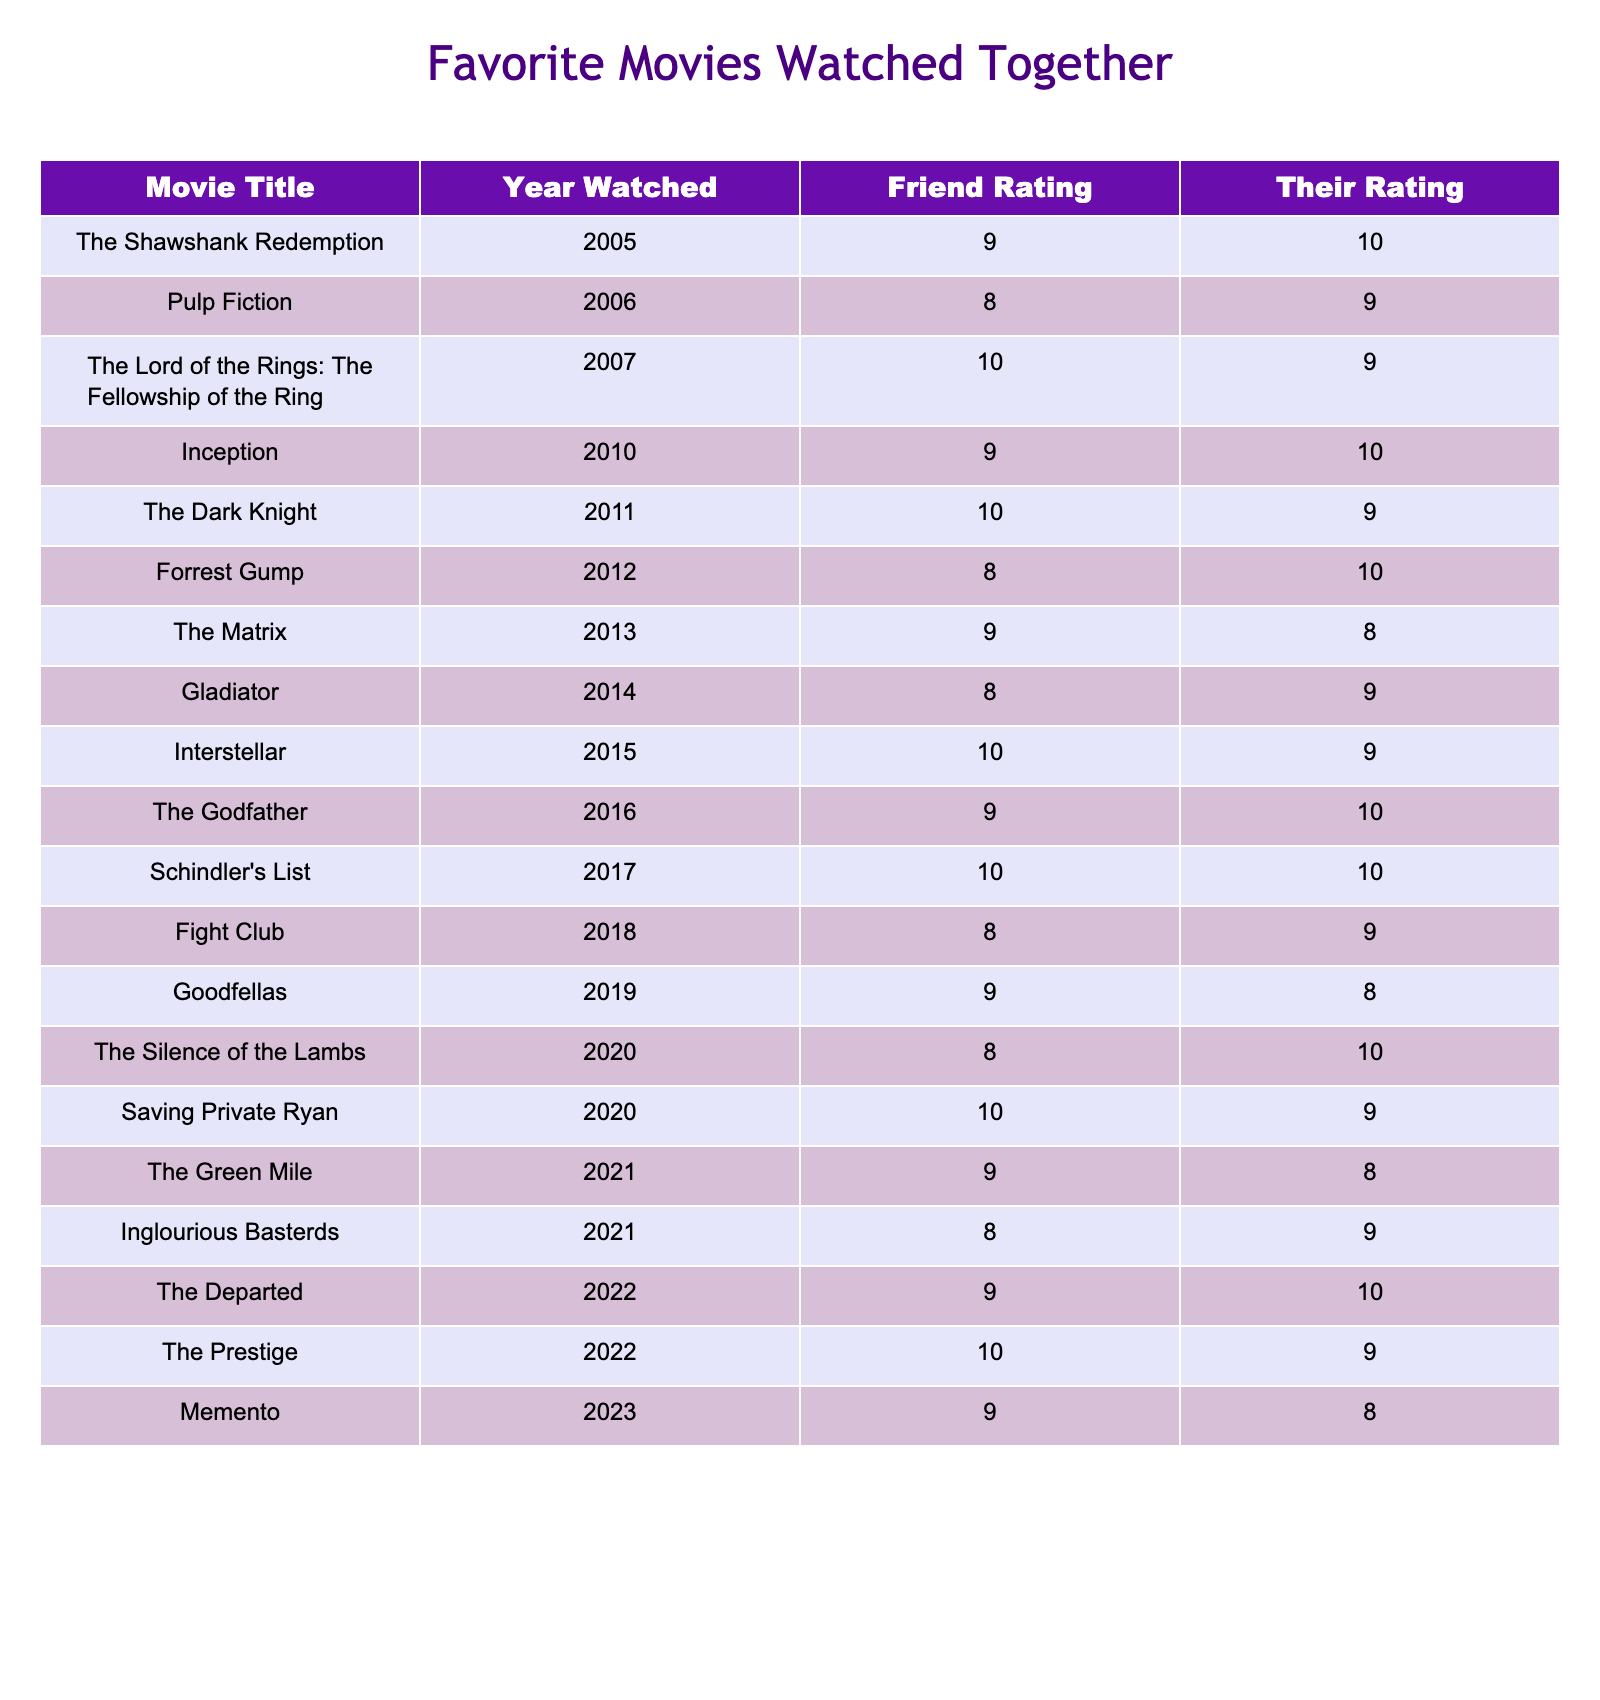What movie did we watch together in 2021? According to the table, the movies watched together in 2021 are "The Green Mile" and "Inglourious Basterds".
Answer: The movies are "The Green Mile" and "Inglourious Basterds" What was my rating for "Inception"? The table shows that my rating for "Inception" in 2010 was 9.
Answer: 9 What is the highest rating you gave for any movie? In the table, the highest rating given by you is 10, which was given to "The Shawshank Redemption," "Inception," "Interstellar," and "Schindler's List."
Answer: 10 What is the average rating I gave for movies from 2015 to 2020? The ratings from 2015 to 2020 are: 10, 9, 8, 10, 8, 9 for a total of 54. There are 6 ratings, so the average is 54/6 = 9.
Answer: 9 Did you rate "The Dark Knight" higher than "Forrest Gump"? My rating for "The Dark Knight" was 9 and for "Forrest Gump" was 10. Since 9 is not higher than 10, the answer is no.
Answer: No Which movie has the largest difference in ratings between us? Looking at the ratings, the largest difference is for "The Shawshank Redemption" where I rated it 9 and you rated it 10, resulting in a difference of 1. Reviewing all movies reveals "The Silence of the Lambs" also has a difference of 2 but with my rating of 8 and your 10, confirming the largest is 2.
Answer: "The Silence of the Lambs" (2) How many movies did we watch that you rated 8? The movies rated 8 by you include: "The Matrix," "Gladiator," "Fight Club," "The Silence of the Lambs," and "Inglourious Basterds," which totals to 5 movies.
Answer: 5 Was there any movie you rated 10 that I rated lower than 10? Yes, "The Dark Knight" and "Interstellar" were rated 10 by you, while I rated them 9.
Answer: Yes What year did we watch "The Godfather"? The table states that we watched "The Godfather" in 2016.
Answer: 2016 What is the sum of all ratings I gave for movies in the 2020s? The movies from the 2020s that I rated are "The Silence of the Lambs" (8), "Saving Private Ryan" (10), "The Green Mile" (9), "Inglourious Basterds" (8), and "The Departed" (9). The sum is 8 + 10 + 9 + 8 + 9 = 54.
Answer: 54 Were there more movies rated 9 by you than by me? By examining the table, there are 6 movies rated 9 by you and 7 by me. Since 6 is less than 7, the answer is no.
Answer: No 